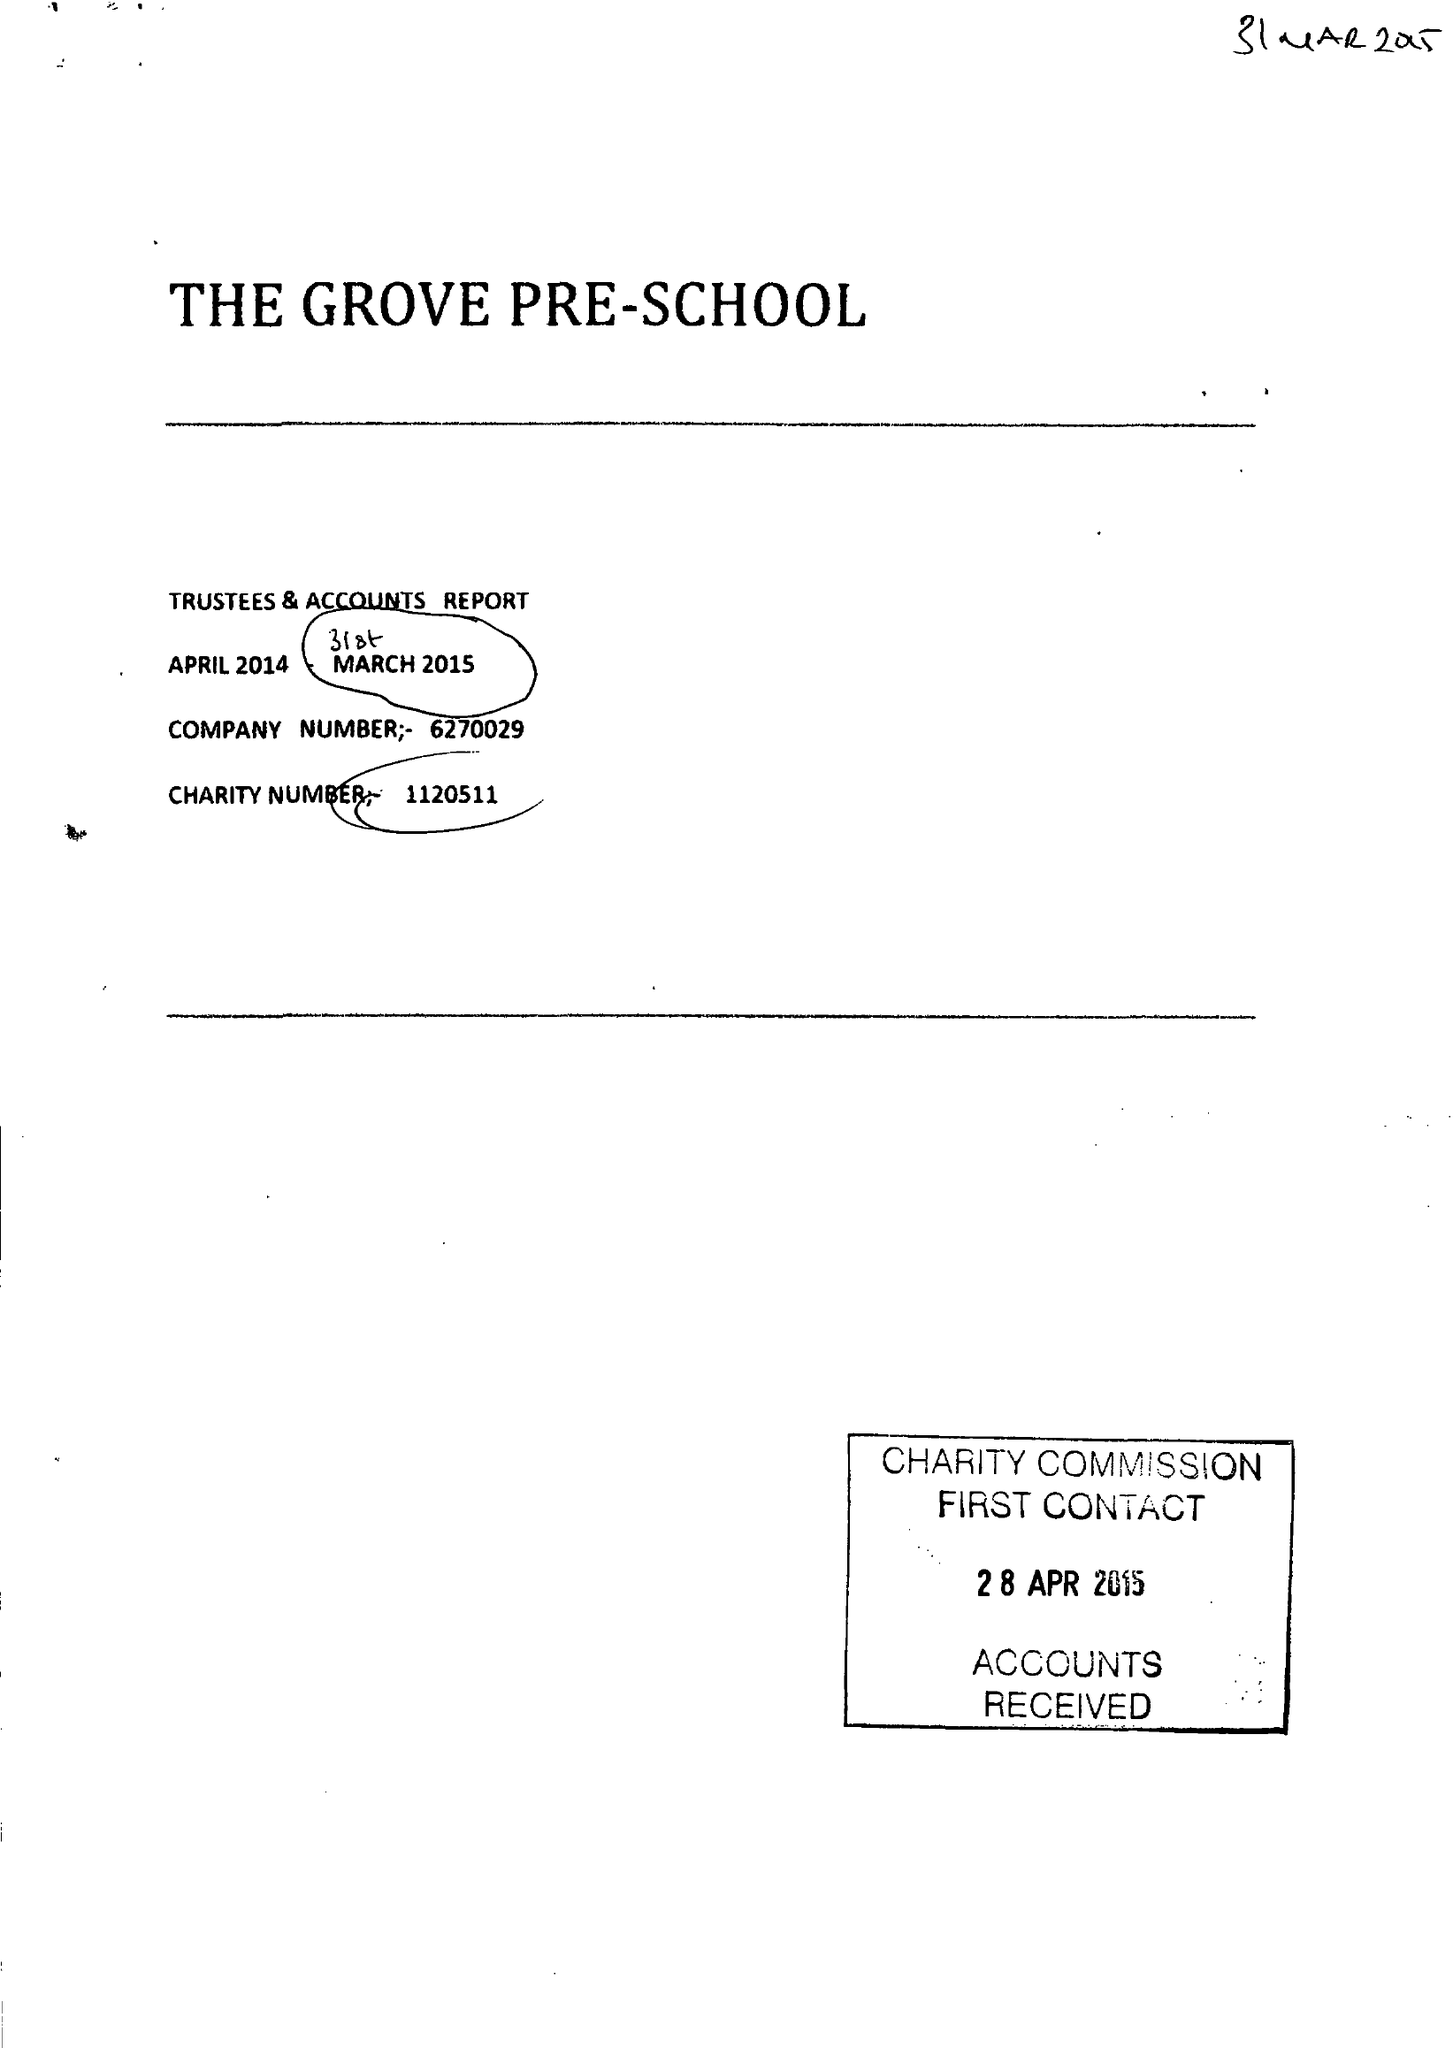What is the value for the spending_annually_in_british_pounds?
Answer the question using a single word or phrase. 64234.00 